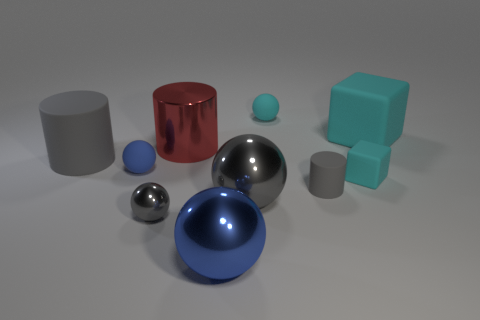Subtract all small matte cylinders. How many cylinders are left? 2 Subtract all red balls. How many gray cylinders are left? 2 Subtract all cyan spheres. How many spheres are left? 4 Add 3 big gray cylinders. How many big gray cylinders exist? 4 Subtract 0 brown balls. How many objects are left? 10 Subtract all cylinders. How many objects are left? 7 Subtract all purple spheres. Subtract all brown blocks. How many spheres are left? 5 Subtract all blue matte spheres. Subtract all large red metallic things. How many objects are left? 8 Add 5 tiny gray rubber things. How many tiny gray rubber things are left? 6 